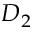Convert formula to latex. <formula><loc_0><loc_0><loc_500><loc_500>D _ { 2 }</formula> 